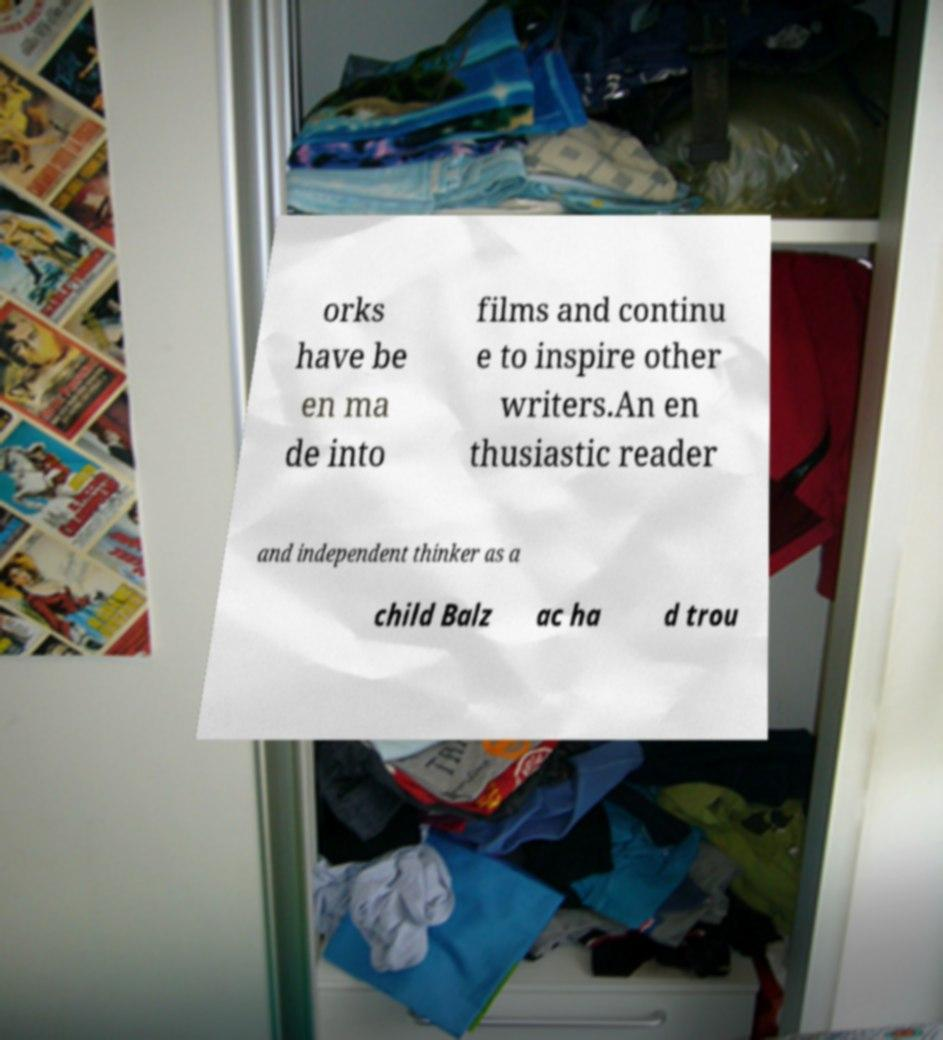What messages or text are displayed in this image? I need them in a readable, typed format. orks have be en ma de into films and continu e to inspire other writers.An en thusiastic reader and independent thinker as a child Balz ac ha d trou 